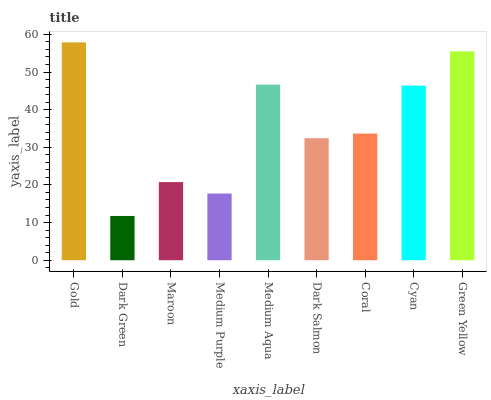Is Dark Green the minimum?
Answer yes or no. Yes. Is Gold the maximum?
Answer yes or no. Yes. Is Maroon the minimum?
Answer yes or no. No. Is Maroon the maximum?
Answer yes or no. No. Is Maroon greater than Dark Green?
Answer yes or no. Yes. Is Dark Green less than Maroon?
Answer yes or no. Yes. Is Dark Green greater than Maroon?
Answer yes or no. No. Is Maroon less than Dark Green?
Answer yes or no. No. Is Coral the high median?
Answer yes or no. Yes. Is Coral the low median?
Answer yes or no. Yes. Is Medium Aqua the high median?
Answer yes or no. No. Is Green Yellow the low median?
Answer yes or no. No. 